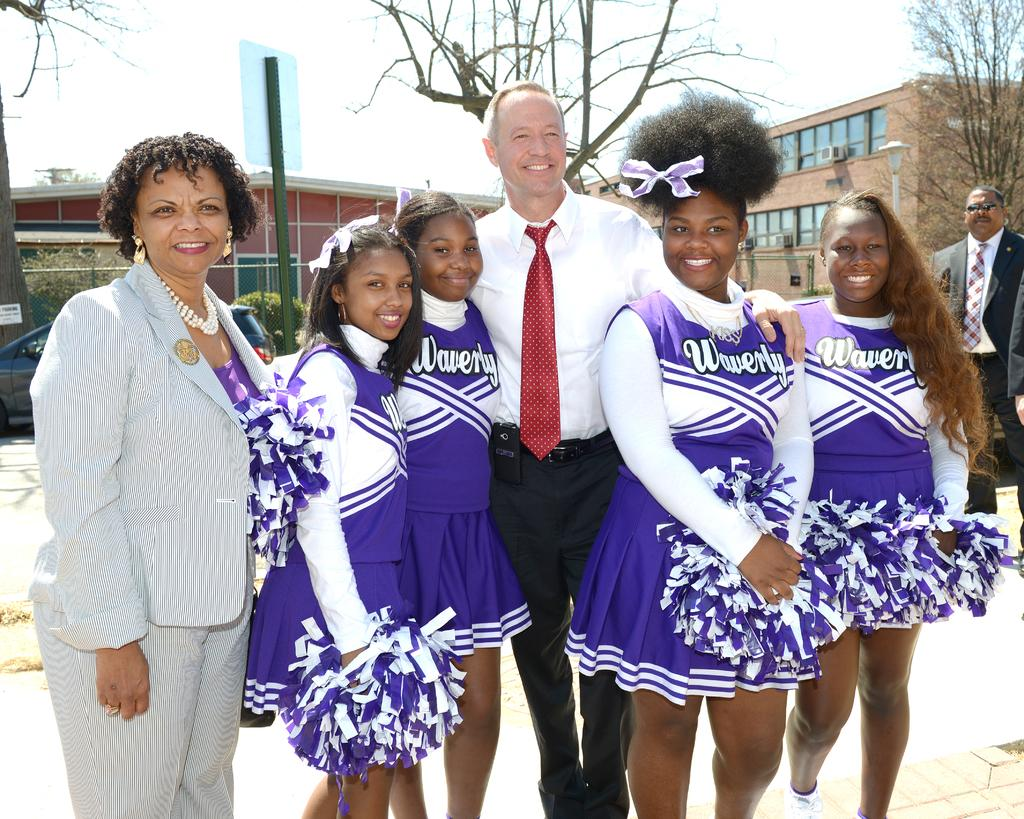<image>
Create a compact narrative representing the image presented. Female cheerleaders from Waverly are posing with adults. 